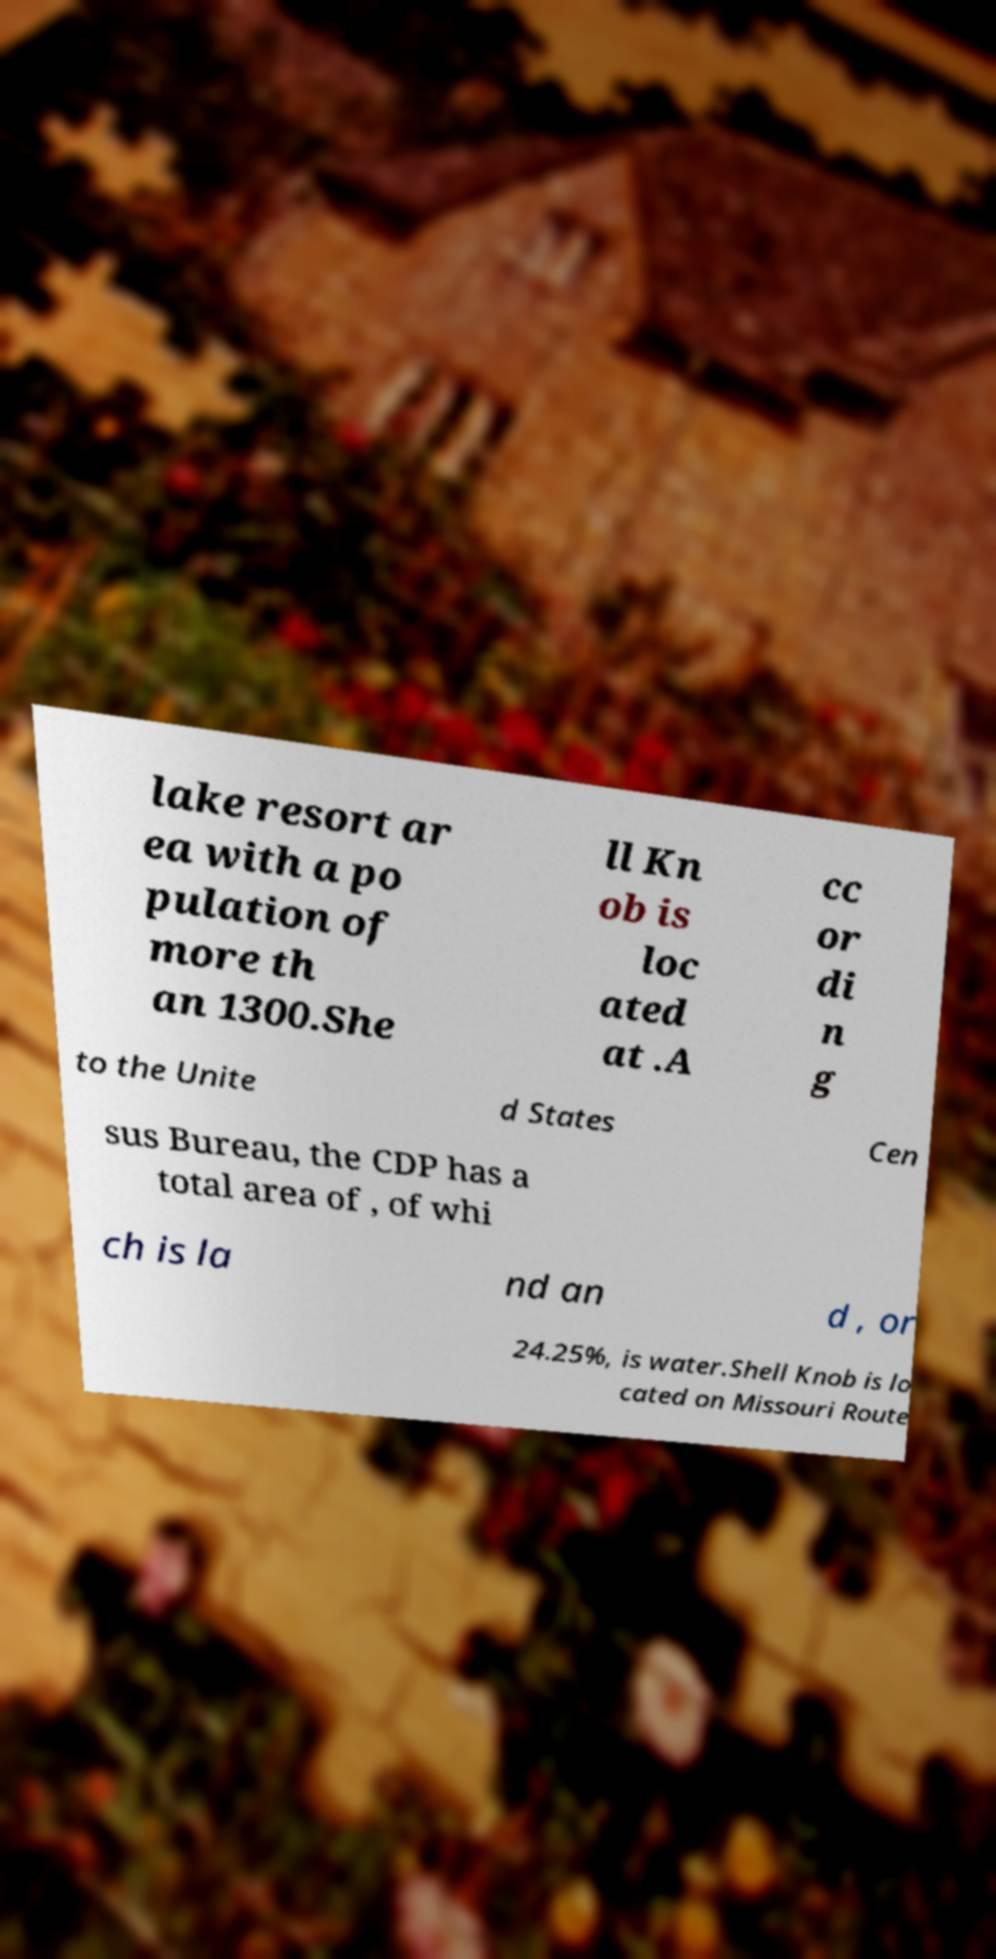Can you accurately transcribe the text from the provided image for me? lake resort ar ea with a po pulation of more th an 1300.She ll Kn ob is loc ated at .A cc or di n g to the Unite d States Cen sus Bureau, the CDP has a total area of , of whi ch is la nd an d , or 24.25%, is water.Shell Knob is lo cated on Missouri Route 